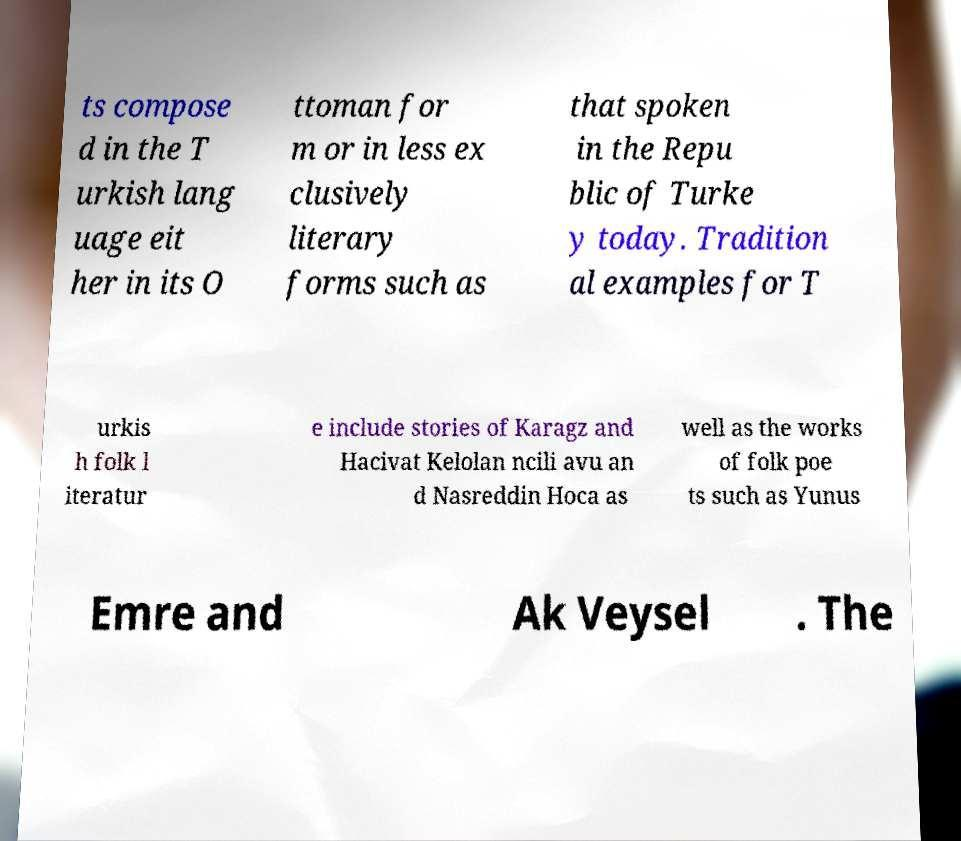What messages or text are displayed in this image? I need them in a readable, typed format. ts compose d in the T urkish lang uage eit her in its O ttoman for m or in less ex clusively literary forms such as that spoken in the Repu blic of Turke y today. Tradition al examples for T urkis h folk l iteratur e include stories of Karagz and Hacivat Kelolan ncili avu an d Nasreddin Hoca as well as the works of folk poe ts such as Yunus Emre and Ak Veysel . The 